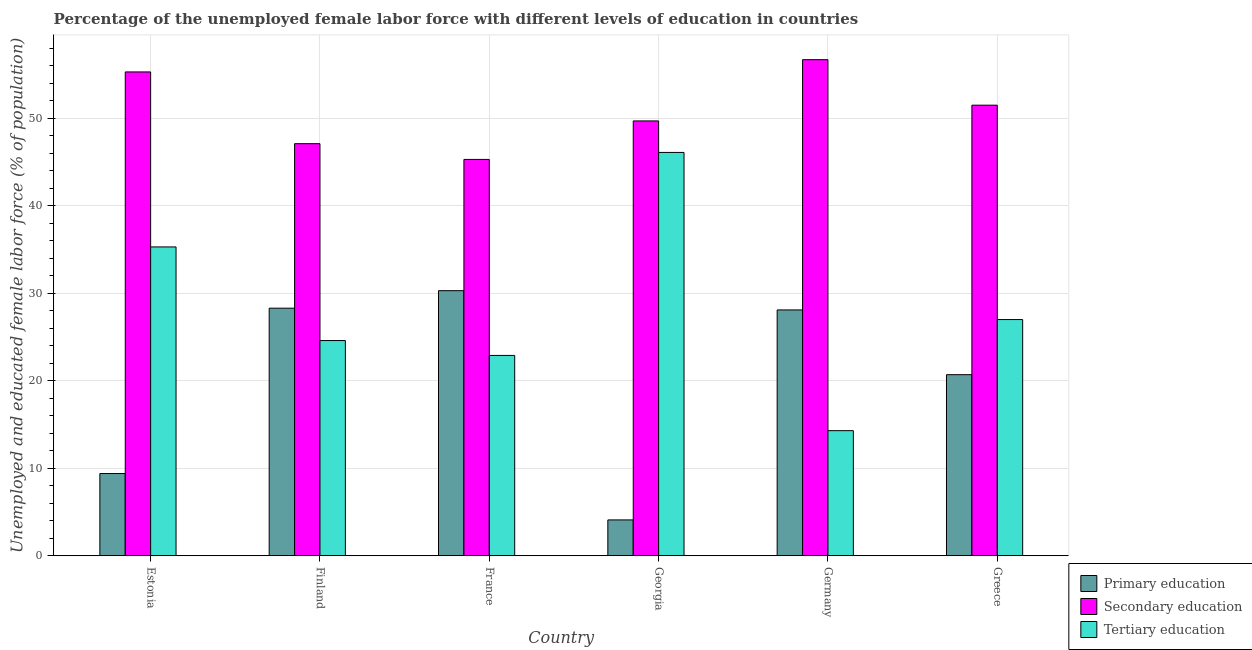How many bars are there on the 3rd tick from the left?
Your response must be concise. 3. How many bars are there on the 1st tick from the right?
Your answer should be very brief. 3. In how many cases, is the number of bars for a given country not equal to the number of legend labels?
Ensure brevity in your answer.  0. What is the percentage of female labor force who received primary education in France?
Offer a terse response. 30.3. Across all countries, what is the maximum percentage of female labor force who received secondary education?
Give a very brief answer. 56.7. Across all countries, what is the minimum percentage of female labor force who received primary education?
Provide a short and direct response. 4.1. In which country was the percentage of female labor force who received primary education maximum?
Give a very brief answer. France. In which country was the percentage of female labor force who received primary education minimum?
Ensure brevity in your answer.  Georgia. What is the total percentage of female labor force who received secondary education in the graph?
Your answer should be compact. 305.6. What is the difference between the percentage of female labor force who received primary education in Germany and that in Greece?
Your answer should be compact. 7.4. What is the difference between the percentage of female labor force who received tertiary education in Germany and the percentage of female labor force who received secondary education in Greece?
Ensure brevity in your answer.  -37.2. What is the average percentage of female labor force who received secondary education per country?
Your response must be concise. 50.93. What is the difference between the percentage of female labor force who received tertiary education and percentage of female labor force who received primary education in France?
Keep it short and to the point. -7.4. What is the ratio of the percentage of female labor force who received tertiary education in Finland to that in Greece?
Ensure brevity in your answer.  0.91. What is the difference between the highest and the second highest percentage of female labor force who received secondary education?
Your answer should be compact. 1.4. What is the difference between the highest and the lowest percentage of female labor force who received primary education?
Provide a short and direct response. 26.2. In how many countries, is the percentage of female labor force who received secondary education greater than the average percentage of female labor force who received secondary education taken over all countries?
Provide a short and direct response. 3. What does the 2nd bar from the left in Germany represents?
Provide a short and direct response. Secondary education. What does the 2nd bar from the right in Georgia represents?
Keep it short and to the point. Secondary education. Is it the case that in every country, the sum of the percentage of female labor force who received primary education and percentage of female labor force who received secondary education is greater than the percentage of female labor force who received tertiary education?
Ensure brevity in your answer.  Yes. How many bars are there?
Your answer should be very brief. 18. How many countries are there in the graph?
Your response must be concise. 6. Does the graph contain grids?
Your response must be concise. Yes. What is the title of the graph?
Your answer should be very brief. Percentage of the unemployed female labor force with different levels of education in countries. What is the label or title of the X-axis?
Provide a succinct answer. Country. What is the label or title of the Y-axis?
Your answer should be very brief. Unemployed and educated female labor force (% of population). What is the Unemployed and educated female labor force (% of population) of Primary education in Estonia?
Offer a terse response. 9.4. What is the Unemployed and educated female labor force (% of population) of Secondary education in Estonia?
Give a very brief answer. 55.3. What is the Unemployed and educated female labor force (% of population) of Tertiary education in Estonia?
Keep it short and to the point. 35.3. What is the Unemployed and educated female labor force (% of population) of Primary education in Finland?
Ensure brevity in your answer.  28.3. What is the Unemployed and educated female labor force (% of population) of Secondary education in Finland?
Your response must be concise. 47.1. What is the Unemployed and educated female labor force (% of population) of Tertiary education in Finland?
Your answer should be compact. 24.6. What is the Unemployed and educated female labor force (% of population) of Primary education in France?
Ensure brevity in your answer.  30.3. What is the Unemployed and educated female labor force (% of population) of Secondary education in France?
Your answer should be very brief. 45.3. What is the Unemployed and educated female labor force (% of population) in Tertiary education in France?
Offer a very short reply. 22.9. What is the Unemployed and educated female labor force (% of population) of Primary education in Georgia?
Offer a very short reply. 4.1. What is the Unemployed and educated female labor force (% of population) of Secondary education in Georgia?
Give a very brief answer. 49.7. What is the Unemployed and educated female labor force (% of population) of Tertiary education in Georgia?
Your answer should be very brief. 46.1. What is the Unemployed and educated female labor force (% of population) of Primary education in Germany?
Provide a short and direct response. 28.1. What is the Unemployed and educated female labor force (% of population) in Secondary education in Germany?
Offer a very short reply. 56.7. What is the Unemployed and educated female labor force (% of population) of Tertiary education in Germany?
Your answer should be very brief. 14.3. What is the Unemployed and educated female labor force (% of population) of Primary education in Greece?
Provide a short and direct response. 20.7. What is the Unemployed and educated female labor force (% of population) of Secondary education in Greece?
Offer a very short reply. 51.5. What is the Unemployed and educated female labor force (% of population) of Tertiary education in Greece?
Make the answer very short. 27. Across all countries, what is the maximum Unemployed and educated female labor force (% of population) of Primary education?
Your answer should be compact. 30.3. Across all countries, what is the maximum Unemployed and educated female labor force (% of population) in Secondary education?
Provide a short and direct response. 56.7. Across all countries, what is the maximum Unemployed and educated female labor force (% of population) in Tertiary education?
Make the answer very short. 46.1. Across all countries, what is the minimum Unemployed and educated female labor force (% of population) in Primary education?
Your response must be concise. 4.1. Across all countries, what is the minimum Unemployed and educated female labor force (% of population) of Secondary education?
Provide a short and direct response. 45.3. Across all countries, what is the minimum Unemployed and educated female labor force (% of population) in Tertiary education?
Offer a very short reply. 14.3. What is the total Unemployed and educated female labor force (% of population) of Primary education in the graph?
Provide a succinct answer. 120.9. What is the total Unemployed and educated female labor force (% of population) of Secondary education in the graph?
Your response must be concise. 305.6. What is the total Unemployed and educated female labor force (% of population) in Tertiary education in the graph?
Your answer should be very brief. 170.2. What is the difference between the Unemployed and educated female labor force (% of population) in Primary education in Estonia and that in Finland?
Your answer should be compact. -18.9. What is the difference between the Unemployed and educated female labor force (% of population) of Secondary education in Estonia and that in Finland?
Provide a succinct answer. 8.2. What is the difference between the Unemployed and educated female labor force (% of population) in Primary education in Estonia and that in France?
Ensure brevity in your answer.  -20.9. What is the difference between the Unemployed and educated female labor force (% of population) in Secondary education in Estonia and that in France?
Make the answer very short. 10. What is the difference between the Unemployed and educated female labor force (% of population) in Tertiary education in Estonia and that in France?
Provide a short and direct response. 12.4. What is the difference between the Unemployed and educated female labor force (% of population) in Primary education in Estonia and that in Georgia?
Offer a terse response. 5.3. What is the difference between the Unemployed and educated female labor force (% of population) in Primary education in Estonia and that in Germany?
Your answer should be compact. -18.7. What is the difference between the Unemployed and educated female labor force (% of population) of Secondary education in Estonia and that in Germany?
Keep it short and to the point. -1.4. What is the difference between the Unemployed and educated female labor force (% of population) of Secondary education in Estonia and that in Greece?
Your response must be concise. 3.8. What is the difference between the Unemployed and educated female labor force (% of population) in Tertiary education in Estonia and that in Greece?
Offer a terse response. 8.3. What is the difference between the Unemployed and educated female labor force (% of population) of Secondary education in Finland and that in France?
Your answer should be compact. 1.8. What is the difference between the Unemployed and educated female labor force (% of population) in Tertiary education in Finland and that in France?
Your answer should be very brief. 1.7. What is the difference between the Unemployed and educated female labor force (% of population) of Primary education in Finland and that in Georgia?
Keep it short and to the point. 24.2. What is the difference between the Unemployed and educated female labor force (% of population) in Secondary education in Finland and that in Georgia?
Offer a terse response. -2.6. What is the difference between the Unemployed and educated female labor force (% of population) of Tertiary education in Finland and that in Georgia?
Your answer should be very brief. -21.5. What is the difference between the Unemployed and educated female labor force (% of population) in Primary education in Finland and that in Germany?
Your answer should be compact. 0.2. What is the difference between the Unemployed and educated female labor force (% of population) in Primary education in Finland and that in Greece?
Provide a succinct answer. 7.6. What is the difference between the Unemployed and educated female labor force (% of population) in Tertiary education in Finland and that in Greece?
Your response must be concise. -2.4. What is the difference between the Unemployed and educated female labor force (% of population) of Primary education in France and that in Georgia?
Give a very brief answer. 26.2. What is the difference between the Unemployed and educated female labor force (% of population) in Tertiary education in France and that in Georgia?
Ensure brevity in your answer.  -23.2. What is the difference between the Unemployed and educated female labor force (% of population) in Primary education in France and that in Germany?
Your answer should be very brief. 2.2. What is the difference between the Unemployed and educated female labor force (% of population) in Tertiary education in France and that in Germany?
Provide a short and direct response. 8.6. What is the difference between the Unemployed and educated female labor force (% of population) of Tertiary education in France and that in Greece?
Keep it short and to the point. -4.1. What is the difference between the Unemployed and educated female labor force (% of population) of Secondary education in Georgia and that in Germany?
Your answer should be compact. -7. What is the difference between the Unemployed and educated female labor force (% of population) of Tertiary education in Georgia and that in Germany?
Your response must be concise. 31.8. What is the difference between the Unemployed and educated female labor force (% of population) of Primary education in Georgia and that in Greece?
Make the answer very short. -16.6. What is the difference between the Unemployed and educated female labor force (% of population) of Primary education in Germany and that in Greece?
Your answer should be compact. 7.4. What is the difference between the Unemployed and educated female labor force (% of population) in Secondary education in Germany and that in Greece?
Offer a very short reply. 5.2. What is the difference between the Unemployed and educated female labor force (% of population) of Tertiary education in Germany and that in Greece?
Offer a very short reply. -12.7. What is the difference between the Unemployed and educated female labor force (% of population) of Primary education in Estonia and the Unemployed and educated female labor force (% of population) of Secondary education in Finland?
Make the answer very short. -37.7. What is the difference between the Unemployed and educated female labor force (% of population) of Primary education in Estonia and the Unemployed and educated female labor force (% of population) of Tertiary education in Finland?
Your answer should be compact. -15.2. What is the difference between the Unemployed and educated female labor force (% of population) in Secondary education in Estonia and the Unemployed and educated female labor force (% of population) in Tertiary education in Finland?
Your answer should be very brief. 30.7. What is the difference between the Unemployed and educated female labor force (% of population) in Primary education in Estonia and the Unemployed and educated female labor force (% of population) in Secondary education in France?
Your answer should be compact. -35.9. What is the difference between the Unemployed and educated female labor force (% of population) in Primary education in Estonia and the Unemployed and educated female labor force (% of population) in Tertiary education in France?
Your response must be concise. -13.5. What is the difference between the Unemployed and educated female labor force (% of population) in Secondary education in Estonia and the Unemployed and educated female labor force (% of population) in Tertiary education in France?
Your response must be concise. 32.4. What is the difference between the Unemployed and educated female labor force (% of population) in Primary education in Estonia and the Unemployed and educated female labor force (% of population) in Secondary education in Georgia?
Provide a short and direct response. -40.3. What is the difference between the Unemployed and educated female labor force (% of population) of Primary education in Estonia and the Unemployed and educated female labor force (% of population) of Tertiary education in Georgia?
Ensure brevity in your answer.  -36.7. What is the difference between the Unemployed and educated female labor force (% of population) in Secondary education in Estonia and the Unemployed and educated female labor force (% of population) in Tertiary education in Georgia?
Your answer should be very brief. 9.2. What is the difference between the Unemployed and educated female labor force (% of population) of Primary education in Estonia and the Unemployed and educated female labor force (% of population) of Secondary education in Germany?
Offer a terse response. -47.3. What is the difference between the Unemployed and educated female labor force (% of population) in Primary education in Estonia and the Unemployed and educated female labor force (% of population) in Tertiary education in Germany?
Ensure brevity in your answer.  -4.9. What is the difference between the Unemployed and educated female labor force (% of population) of Primary education in Estonia and the Unemployed and educated female labor force (% of population) of Secondary education in Greece?
Keep it short and to the point. -42.1. What is the difference between the Unemployed and educated female labor force (% of population) in Primary education in Estonia and the Unemployed and educated female labor force (% of population) in Tertiary education in Greece?
Your answer should be compact. -17.6. What is the difference between the Unemployed and educated female labor force (% of population) in Secondary education in Estonia and the Unemployed and educated female labor force (% of population) in Tertiary education in Greece?
Your answer should be very brief. 28.3. What is the difference between the Unemployed and educated female labor force (% of population) in Primary education in Finland and the Unemployed and educated female labor force (% of population) in Secondary education in France?
Give a very brief answer. -17. What is the difference between the Unemployed and educated female labor force (% of population) of Secondary education in Finland and the Unemployed and educated female labor force (% of population) of Tertiary education in France?
Your response must be concise. 24.2. What is the difference between the Unemployed and educated female labor force (% of population) in Primary education in Finland and the Unemployed and educated female labor force (% of population) in Secondary education in Georgia?
Make the answer very short. -21.4. What is the difference between the Unemployed and educated female labor force (% of population) in Primary education in Finland and the Unemployed and educated female labor force (% of population) in Tertiary education in Georgia?
Offer a terse response. -17.8. What is the difference between the Unemployed and educated female labor force (% of population) in Secondary education in Finland and the Unemployed and educated female labor force (% of population) in Tertiary education in Georgia?
Your response must be concise. 1. What is the difference between the Unemployed and educated female labor force (% of population) in Primary education in Finland and the Unemployed and educated female labor force (% of population) in Secondary education in Germany?
Keep it short and to the point. -28.4. What is the difference between the Unemployed and educated female labor force (% of population) of Secondary education in Finland and the Unemployed and educated female labor force (% of population) of Tertiary education in Germany?
Give a very brief answer. 32.8. What is the difference between the Unemployed and educated female labor force (% of population) of Primary education in Finland and the Unemployed and educated female labor force (% of population) of Secondary education in Greece?
Give a very brief answer. -23.2. What is the difference between the Unemployed and educated female labor force (% of population) in Secondary education in Finland and the Unemployed and educated female labor force (% of population) in Tertiary education in Greece?
Ensure brevity in your answer.  20.1. What is the difference between the Unemployed and educated female labor force (% of population) of Primary education in France and the Unemployed and educated female labor force (% of population) of Secondary education in Georgia?
Give a very brief answer. -19.4. What is the difference between the Unemployed and educated female labor force (% of population) in Primary education in France and the Unemployed and educated female labor force (% of population) in Tertiary education in Georgia?
Your response must be concise. -15.8. What is the difference between the Unemployed and educated female labor force (% of population) in Primary education in France and the Unemployed and educated female labor force (% of population) in Secondary education in Germany?
Offer a terse response. -26.4. What is the difference between the Unemployed and educated female labor force (% of population) of Primary education in France and the Unemployed and educated female labor force (% of population) of Secondary education in Greece?
Ensure brevity in your answer.  -21.2. What is the difference between the Unemployed and educated female labor force (% of population) in Secondary education in France and the Unemployed and educated female labor force (% of population) in Tertiary education in Greece?
Give a very brief answer. 18.3. What is the difference between the Unemployed and educated female labor force (% of population) of Primary education in Georgia and the Unemployed and educated female labor force (% of population) of Secondary education in Germany?
Make the answer very short. -52.6. What is the difference between the Unemployed and educated female labor force (% of population) in Primary education in Georgia and the Unemployed and educated female labor force (% of population) in Tertiary education in Germany?
Offer a terse response. -10.2. What is the difference between the Unemployed and educated female labor force (% of population) of Secondary education in Georgia and the Unemployed and educated female labor force (% of population) of Tertiary education in Germany?
Offer a terse response. 35.4. What is the difference between the Unemployed and educated female labor force (% of population) of Primary education in Georgia and the Unemployed and educated female labor force (% of population) of Secondary education in Greece?
Your answer should be very brief. -47.4. What is the difference between the Unemployed and educated female labor force (% of population) in Primary education in Georgia and the Unemployed and educated female labor force (% of population) in Tertiary education in Greece?
Make the answer very short. -22.9. What is the difference between the Unemployed and educated female labor force (% of population) of Secondary education in Georgia and the Unemployed and educated female labor force (% of population) of Tertiary education in Greece?
Give a very brief answer. 22.7. What is the difference between the Unemployed and educated female labor force (% of population) in Primary education in Germany and the Unemployed and educated female labor force (% of population) in Secondary education in Greece?
Your answer should be very brief. -23.4. What is the difference between the Unemployed and educated female labor force (% of population) in Primary education in Germany and the Unemployed and educated female labor force (% of population) in Tertiary education in Greece?
Offer a very short reply. 1.1. What is the difference between the Unemployed and educated female labor force (% of population) in Secondary education in Germany and the Unemployed and educated female labor force (% of population) in Tertiary education in Greece?
Ensure brevity in your answer.  29.7. What is the average Unemployed and educated female labor force (% of population) of Primary education per country?
Offer a terse response. 20.15. What is the average Unemployed and educated female labor force (% of population) of Secondary education per country?
Your answer should be compact. 50.93. What is the average Unemployed and educated female labor force (% of population) of Tertiary education per country?
Offer a terse response. 28.37. What is the difference between the Unemployed and educated female labor force (% of population) in Primary education and Unemployed and educated female labor force (% of population) in Secondary education in Estonia?
Provide a short and direct response. -45.9. What is the difference between the Unemployed and educated female labor force (% of population) in Primary education and Unemployed and educated female labor force (% of population) in Tertiary education in Estonia?
Give a very brief answer. -25.9. What is the difference between the Unemployed and educated female labor force (% of population) of Secondary education and Unemployed and educated female labor force (% of population) of Tertiary education in Estonia?
Offer a very short reply. 20. What is the difference between the Unemployed and educated female labor force (% of population) in Primary education and Unemployed and educated female labor force (% of population) in Secondary education in Finland?
Give a very brief answer. -18.8. What is the difference between the Unemployed and educated female labor force (% of population) of Primary education and Unemployed and educated female labor force (% of population) of Tertiary education in Finland?
Make the answer very short. 3.7. What is the difference between the Unemployed and educated female labor force (% of population) in Secondary education and Unemployed and educated female labor force (% of population) in Tertiary education in Finland?
Give a very brief answer. 22.5. What is the difference between the Unemployed and educated female labor force (% of population) of Secondary education and Unemployed and educated female labor force (% of population) of Tertiary education in France?
Keep it short and to the point. 22.4. What is the difference between the Unemployed and educated female labor force (% of population) of Primary education and Unemployed and educated female labor force (% of population) of Secondary education in Georgia?
Your answer should be compact. -45.6. What is the difference between the Unemployed and educated female labor force (% of population) of Primary education and Unemployed and educated female labor force (% of population) of Tertiary education in Georgia?
Provide a short and direct response. -42. What is the difference between the Unemployed and educated female labor force (% of population) in Secondary education and Unemployed and educated female labor force (% of population) in Tertiary education in Georgia?
Ensure brevity in your answer.  3.6. What is the difference between the Unemployed and educated female labor force (% of population) in Primary education and Unemployed and educated female labor force (% of population) in Secondary education in Germany?
Give a very brief answer. -28.6. What is the difference between the Unemployed and educated female labor force (% of population) in Primary education and Unemployed and educated female labor force (% of population) in Tertiary education in Germany?
Ensure brevity in your answer.  13.8. What is the difference between the Unemployed and educated female labor force (% of population) in Secondary education and Unemployed and educated female labor force (% of population) in Tertiary education in Germany?
Keep it short and to the point. 42.4. What is the difference between the Unemployed and educated female labor force (% of population) in Primary education and Unemployed and educated female labor force (% of population) in Secondary education in Greece?
Offer a terse response. -30.8. What is the difference between the Unemployed and educated female labor force (% of population) of Primary education and Unemployed and educated female labor force (% of population) of Tertiary education in Greece?
Give a very brief answer. -6.3. What is the ratio of the Unemployed and educated female labor force (% of population) in Primary education in Estonia to that in Finland?
Offer a very short reply. 0.33. What is the ratio of the Unemployed and educated female labor force (% of population) in Secondary education in Estonia to that in Finland?
Keep it short and to the point. 1.17. What is the ratio of the Unemployed and educated female labor force (% of population) of Tertiary education in Estonia to that in Finland?
Offer a terse response. 1.44. What is the ratio of the Unemployed and educated female labor force (% of population) in Primary education in Estonia to that in France?
Offer a very short reply. 0.31. What is the ratio of the Unemployed and educated female labor force (% of population) in Secondary education in Estonia to that in France?
Provide a succinct answer. 1.22. What is the ratio of the Unemployed and educated female labor force (% of population) in Tertiary education in Estonia to that in France?
Provide a succinct answer. 1.54. What is the ratio of the Unemployed and educated female labor force (% of population) in Primary education in Estonia to that in Georgia?
Give a very brief answer. 2.29. What is the ratio of the Unemployed and educated female labor force (% of population) of Secondary education in Estonia to that in Georgia?
Ensure brevity in your answer.  1.11. What is the ratio of the Unemployed and educated female labor force (% of population) of Tertiary education in Estonia to that in Georgia?
Provide a succinct answer. 0.77. What is the ratio of the Unemployed and educated female labor force (% of population) of Primary education in Estonia to that in Germany?
Keep it short and to the point. 0.33. What is the ratio of the Unemployed and educated female labor force (% of population) of Secondary education in Estonia to that in Germany?
Provide a short and direct response. 0.98. What is the ratio of the Unemployed and educated female labor force (% of population) of Tertiary education in Estonia to that in Germany?
Provide a short and direct response. 2.47. What is the ratio of the Unemployed and educated female labor force (% of population) of Primary education in Estonia to that in Greece?
Provide a short and direct response. 0.45. What is the ratio of the Unemployed and educated female labor force (% of population) of Secondary education in Estonia to that in Greece?
Your answer should be compact. 1.07. What is the ratio of the Unemployed and educated female labor force (% of population) of Tertiary education in Estonia to that in Greece?
Offer a very short reply. 1.31. What is the ratio of the Unemployed and educated female labor force (% of population) of Primary education in Finland to that in France?
Your answer should be very brief. 0.93. What is the ratio of the Unemployed and educated female labor force (% of population) of Secondary education in Finland to that in France?
Your answer should be very brief. 1.04. What is the ratio of the Unemployed and educated female labor force (% of population) of Tertiary education in Finland to that in France?
Ensure brevity in your answer.  1.07. What is the ratio of the Unemployed and educated female labor force (% of population) in Primary education in Finland to that in Georgia?
Your answer should be compact. 6.9. What is the ratio of the Unemployed and educated female labor force (% of population) of Secondary education in Finland to that in Georgia?
Your answer should be compact. 0.95. What is the ratio of the Unemployed and educated female labor force (% of population) of Tertiary education in Finland to that in Georgia?
Your answer should be compact. 0.53. What is the ratio of the Unemployed and educated female labor force (% of population) in Primary education in Finland to that in Germany?
Your answer should be very brief. 1.01. What is the ratio of the Unemployed and educated female labor force (% of population) in Secondary education in Finland to that in Germany?
Keep it short and to the point. 0.83. What is the ratio of the Unemployed and educated female labor force (% of population) of Tertiary education in Finland to that in Germany?
Offer a terse response. 1.72. What is the ratio of the Unemployed and educated female labor force (% of population) in Primary education in Finland to that in Greece?
Offer a terse response. 1.37. What is the ratio of the Unemployed and educated female labor force (% of population) of Secondary education in Finland to that in Greece?
Keep it short and to the point. 0.91. What is the ratio of the Unemployed and educated female labor force (% of population) in Tertiary education in Finland to that in Greece?
Give a very brief answer. 0.91. What is the ratio of the Unemployed and educated female labor force (% of population) of Primary education in France to that in Georgia?
Provide a succinct answer. 7.39. What is the ratio of the Unemployed and educated female labor force (% of population) of Secondary education in France to that in Georgia?
Make the answer very short. 0.91. What is the ratio of the Unemployed and educated female labor force (% of population) of Tertiary education in France to that in Georgia?
Provide a short and direct response. 0.5. What is the ratio of the Unemployed and educated female labor force (% of population) of Primary education in France to that in Germany?
Give a very brief answer. 1.08. What is the ratio of the Unemployed and educated female labor force (% of population) of Secondary education in France to that in Germany?
Ensure brevity in your answer.  0.8. What is the ratio of the Unemployed and educated female labor force (% of population) in Tertiary education in France to that in Germany?
Make the answer very short. 1.6. What is the ratio of the Unemployed and educated female labor force (% of population) of Primary education in France to that in Greece?
Offer a very short reply. 1.46. What is the ratio of the Unemployed and educated female labor force (% of population) of Secondary education in France to that in Greece?
Your response must be concise. 0.88. What is the ratio of the Unemployed and educated female labor force (% of population) of Tertiary education in France to that in Greece?
Your response must be concise. 0.85. What is the ratio of the Unemployed and educated female labor force (% of population) in Primary education in Georgia to that in Germany?
Ensure brevity in your answer.  0.15. What is the ratio of the Unemployed and educated female labor force (% of population) of Secondary education in Georgia to that in Germany?
Your answer should be compact. 0.88. What is the ratio of the Unemployed and educated female labor force (% of population) of Tertiary education in Georgia to that in Germany?
Your answer should be very brief. 3.22. What is the ratio of the Unemployed and educated female labor force (% of population) of Primary education in Georgia to that in Greece?
Offer a terse response. 0.2. What is the ratio of the Unemployed and educated female labor force (% of population) in Tertiary education in Georgia to that in Greece?
Keep it short and to the point. 1.71. What is the ratio of the Unemployed and educated female labor force (% of population) in Primary education in Germany to that in Greece?
Provide a short and direct response. 1.36. What is the ratio of the Unemployed and educated female labor force (% of population) of Secondary education in Germany to that in Greece?
Give a very brief answer. 1.1. What is the ratio of the Unemployed and educated female labor force (% of population) of Tertiary education in Germany to that in Greece?
Provide a succinct answer. 0.53. What is the difference between the highest and the second highest Unemployed and educated female labor force (% of population) of Primary education?
Offer a terse response. 2. What is the difference between the highest and the second highest Unemployed and educated female labor force (% of population) of Secondary education?
Offer a very short reply. 1.4. What is the difference between the highest and the lowest Unemployed and educated female labor force (% of population) in Primary education?
Your answer should be compact. 26.2. What is the difference between the highest and the lowest Unemployed and educated female labor force (% of population) in Tertiary education?
Your answer should be very brief. 31.8. 